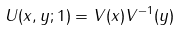<formula> <loc_0><loc_0><loc_500><loc_500>U ( x , y ; 1 ) = V ( x ) V ^ { - 1 } ( y )</formula> 